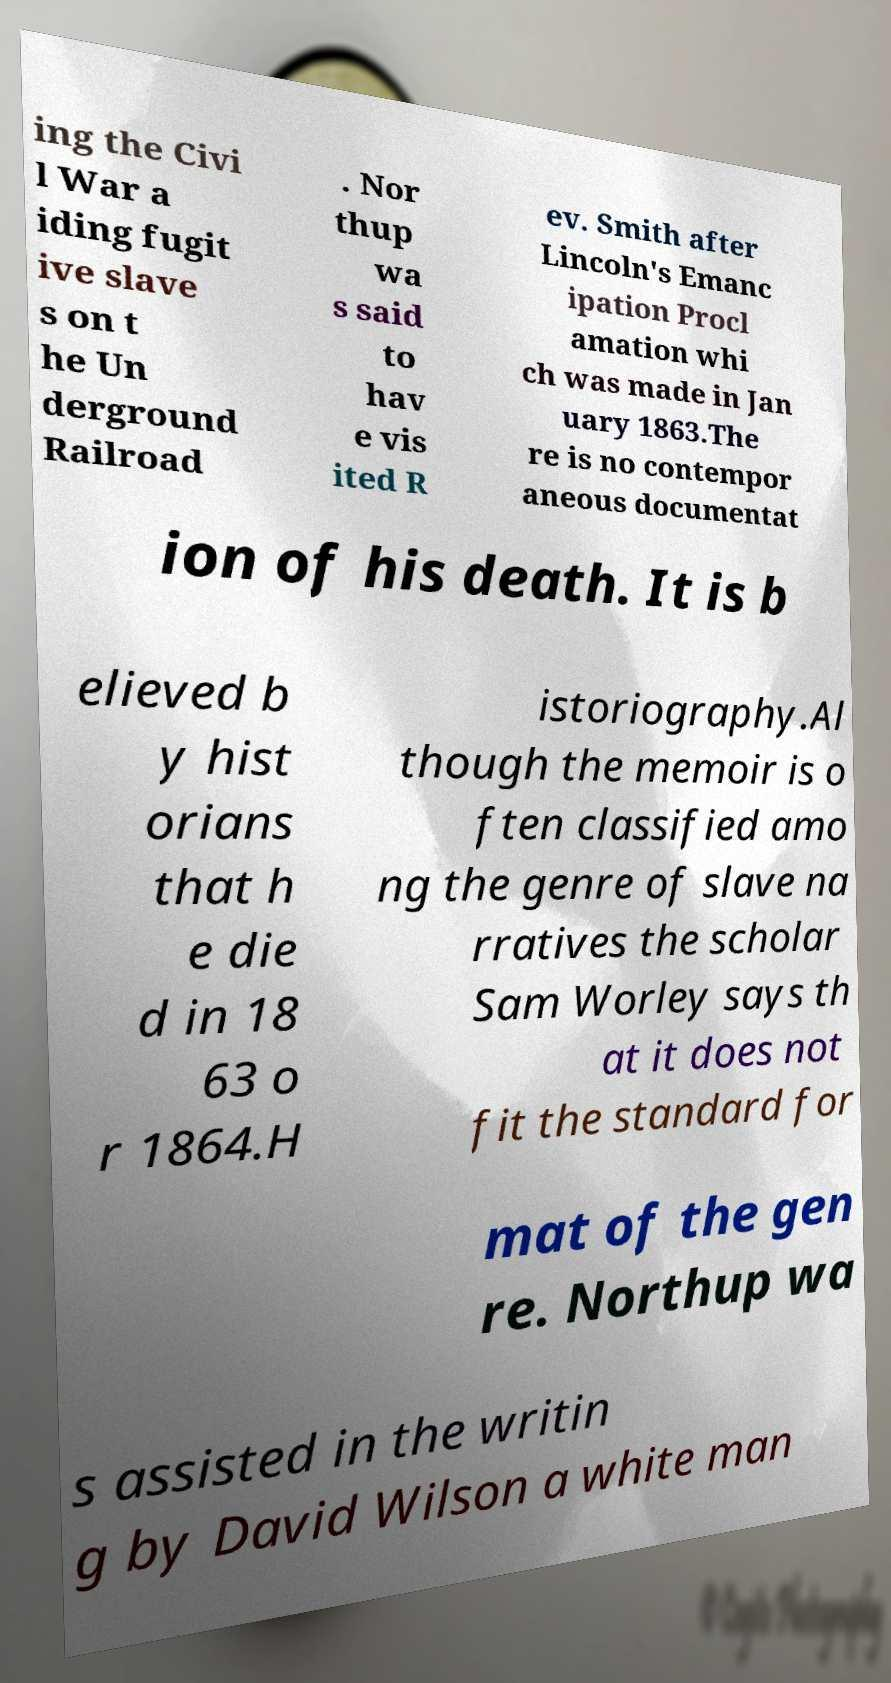Could you assist in decoding the text presented in this image and type it out clearly? ing the Civi l War a iding fugit ive slave s on t he Un derground Railroad . Nor thup wa s said to hav e vis ited R ev. Smith after Lincoln's Emanc ipation Procl amation whi ch was made in Jan uary 1863.The re is no contempor aneous documentat ion of his death. It is b elieved b y hist orians that h e die d in 18 63 o r 1864.H istoriography.Al though the memoir is o ften classified amo ng the genre of slave na rratives the scholar Sam Worley says th at it does not fit the standard for mat of the gen re. Northup wa s assisted in the writin g by David Wilson a white man 